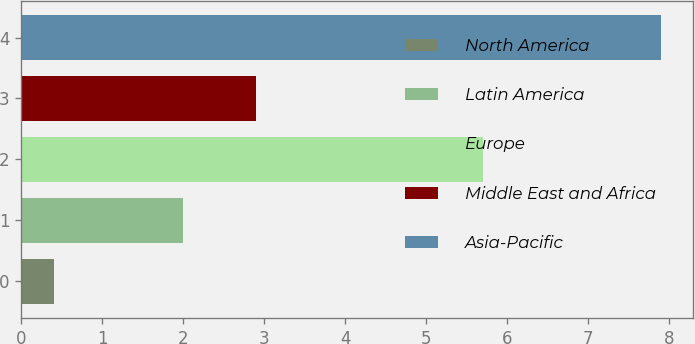Convert chart to OTSL. <chart><loc_0><loc_0><loc_500><loc_500><bar_chart><fcel>North America<fcel>Latin America<fcel>Europe<fcel>Middle East and Africa<fcel>Asia-Pacific<nl><fcel>0.4<fcel>2<fcel>5.7<fcel>2.9<fcel>7.9<nl></chart> 